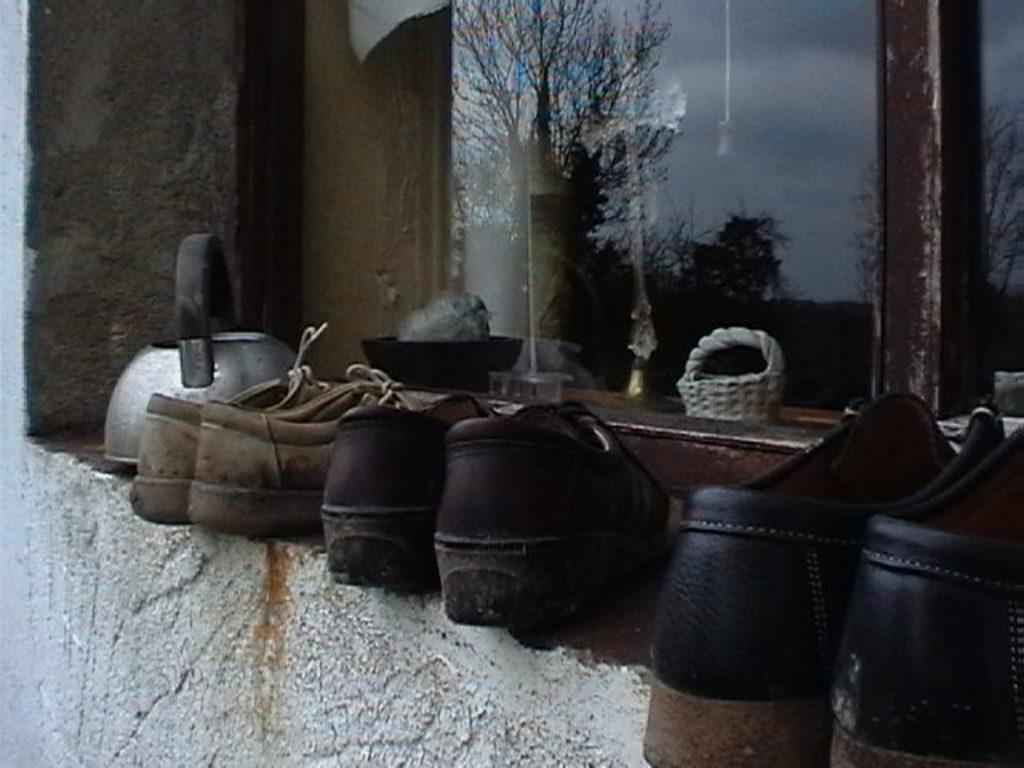What object can be seen in the image that is typically used for serving hot beverages? There is a teapot in the image. What type of footwear is present in the image? There are a pair of shoes in the image. What can be seen reflected on a glass surface in the image? There is a reflection of trees on a glass in the image. What items can be seen through the glass in the image? A basket and a bowl are visible through the glass. What type of sponge is being used to clean the teapot in the image? There is no sponge present in the image, and the teapot is not being cleaned. How does the sun affect the visibility of the pair of shoes in the image? The image does not show the sun, and its effect on the visibility of the shoes cannot be determined. 